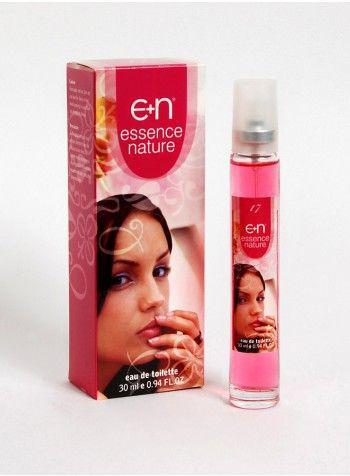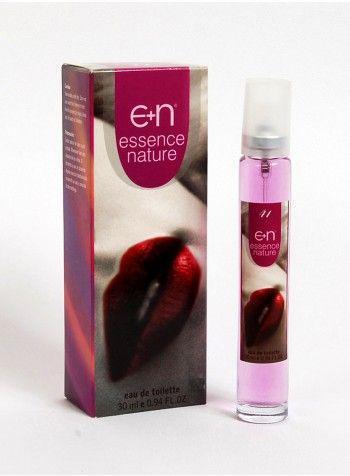The first image is the image on the left, the second image is the image on the right. Examine the images to the left and right. Is the description "The box for the product in the image on the left shows a woman's face." accurate? Answer yes or no. Yes. The first image is the image on the left, the second image is the image on the right. Evaluate the accuracy of this statement regarding the images: "At least one image shows a spray product standing next to its box.". Is it true? Answer yes or no. Yes. 